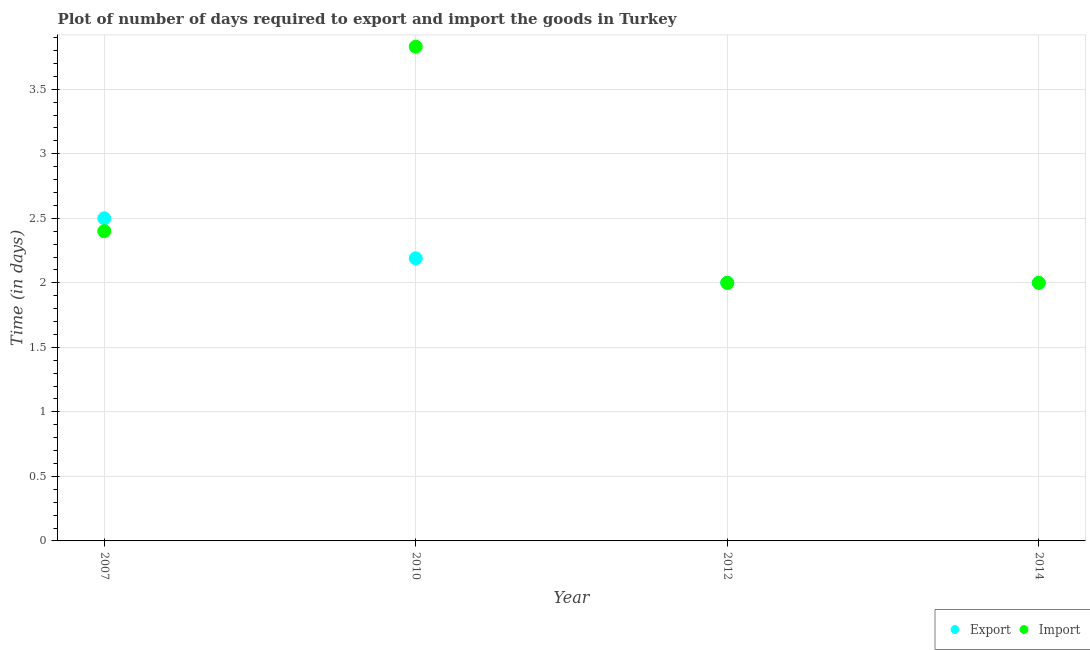Across all years, what is the maximum time required to import?
Make the answer very short. 3.83. In which year was the time required to export maximum?
Give a very brief answer. 2007. In which year was the time required to import minimum?
Give a very brief answer. 2012. What is the total time required to export in the graph?
Keep it short and to the point. 8.69. What is the difference between the time required to import in 2007 and that in 2012?
Make the answer very short. 0.4. What is the difference between the time required to import in 2007 and the time required to export in 2014?
Your response must be concise. 0.4. What is the average time required to export per year?
Your answer should be compact. 2.17. In the year 2007, what is the difference between the time required to export and time required to import?
Offer a terse response. 0.1. In how many years, is the time required to export greater than 0.8 days?
Make the answer very short. 4. What is the ratio of the time required to import in 2012 to that in 2014?
Your answer should be compact. 1. Is the time required to import in 2007 less than that in 2010?
Ensure brevity in your answer.  Yes. What is the difference between the highest and the second highest time required to export?
Provide a succinct answer. 0.31. What is the difference between the highest and the lowest time required to import?
Your answer should be compact. 1.83. In how many years, is the time required to import greater than the average time required to import taken over all years?
Make the answer very short. 1. Is the sum of the time required to export in 2007 and 2014 greater than the maximum time required to import across all years?
Ensure brevity in your answer.  Yes. Does the time required to import monotonically increase over the years?
Provide a succinct answer. No. How many dotlines are there?
Provide a succinct answer. 2. How many years are there in the graph?
Ensure brevity in your answer.  4. Does the graph contain any zero values?
Your answer should be very brief. No. Where does the legend appear in the graph?
Your answer should be very brief. Bottom right. How are the legend labels stacked?
Provide a short and direct response. Horizontal. What is the title of the graph?
Make the answer very short. Plot of number of days required to export and import the goods in Turkey. What is the label or title of the X-axis?
Offer a very short reply. Year. What is the label or title of the Y-axis?
Ensure brevity in your answer.  Time (in days). What is the Time (in days) of Export in 2007?
Your answer should be compact. 2.5. What is the Time (in days) in Import in 2007?
Offer a terse response. 2.4. What is the Time (in days) in Export in 2010?
Your answer should be very brief. 2.19. What is the Time (in days) in Import in 2010?
Your answer should be compact. 3.83. What is the Time (in days) of Import in 2012?
Ensure brevity in your answer.  2. What is the Time (in days) in Export in 2014?
Ensure brevity in your answer.  2. Across all years, what is the maximum Time (in days) in Import?
Provide a succinct answer. 3.83. Across all years, what is the minimum Time (in days) in Import?
Offer a very short reply. 2. What is the total Time (in days) of Export in the graph?
Keep it short and to the point. 8.69. What is the total Time (in days) of Import in the graph?
Provide a succinct answer. 10.23. What is the difference between the Time (in days) of Export in 2007 and that in 2010?
Give a very brief answer. 0.31. What is the difference between the Time (in days) of Import in 2007 and that in 2010?
Your answer should be compact. -1.43. What is the difference between the Time (in days) in Import in 2007 and that in 2012?
Ensure brevity in your answer.  0.4. What is the difference between the Time (in days) in Export in 2007 and that in 2014?
Ensure brevity in your answer.  0.5. What is the difference between the Time (in days) in Import in 2007 and that in 2014?
Make the answer very short. 0.4. What is the difference between the Time (in days) of Export in 2010 and that in 2012?
Provide a short and direct response. 0.19. What is the difference between the Time (in days) of Import in 2010 and that in 2012?
Keep it short and to the point. 1.83. What is the difference between the Time (in days) in Export in 2010 and that in 2014?
Ensure brevity in your answer.  0.19. What is the difference between the Time (in days) in Import in 2010 and that in 2014?
Ensure brevity in your answer.  1.83. What is the difference between the Time (in days) in Export in 2007 and the Time (in days) in Import in 2010?
Make the answer very short. -1.33. What is the difference between the Time (in days) of Export in 2007 and the Time (in days) of Import in 2012?
Your response must be concise. 0.5. What is the difference between the Time (in days) of Export in 2007 and the Time (in days) of Import in 2014?
Make the answer very short. 0.5. What is the difference between the Time (in days) in Export in 2010 and the Time (in days) in Import in 2012?
Make the answer very short. 0.19. What is the difference between the Time (in days) in Export in 2010 and the Time (in days) in Import in 2014?
Provide a short and direct response. 0.19. What is the average Time (in days) in Export per year?
Your response must be concise. 2.17. What is the average Time (in days) of Import per year?
Your answer should be compact. 2.56. In the year 2007, what is the difference between the Time (in days) in Export and Time (in days) in Import?
Your response must be concise. 0.1. In the year 2010, what is the difference between the Time (in days) in Export and Time (in days) in Import?
Provide a short and direct response. -1.64. In the year 2012, what is the difference between the Time (in days) in Export and Time (in days) in Import?
Ensure brevity in your answer.  0. What is the ratio of the Time (in days) in Export in 2007 to that in 2010?
Give a very brief answer. 1.14. What is the ratio of the Time (in days) of Import in 2007 to that in 2010?
Offer a terse response. 0.63. What is the ratio of the Time (in days) in Import in 2007 to that in 2014?
Make the answer very short. 1.2. What is the ratio of the Time (in days) in Export in 2010 to that in 2012?
Provide a succinct answer. 1.09. What is the ratio of the Time (in days) of Import in 2010 to that in 2012?
Offer a very short reply. 1.92. What is the ratio of the Time (in days) in Export in 2010 to that in 2014?
Your answer should be compact. 1.09. What is the ratio of the Time (in days) in Import in 2010 to that in 2014?
Offer a terse response. 1.92. What is the ratio of the Time (in days) of Export in 2012 to that in 2014?
Give a very brief answer. 1. What is the ratio of the Time (in days) of Import in 2012 to that in 2014?
Provide a succinct answer. 1. What is the difference between the highest and the second highest Time (in days) in Export?
Provide a short and direct response. 0.31. What is the difference between the highest and the second highest Time (in days) of Import?
Your answer should be compact. 1.43. What is the difference between the highest and the lowest Time (in days) in Import?
Ensure brevity in your answer.  1.83. 